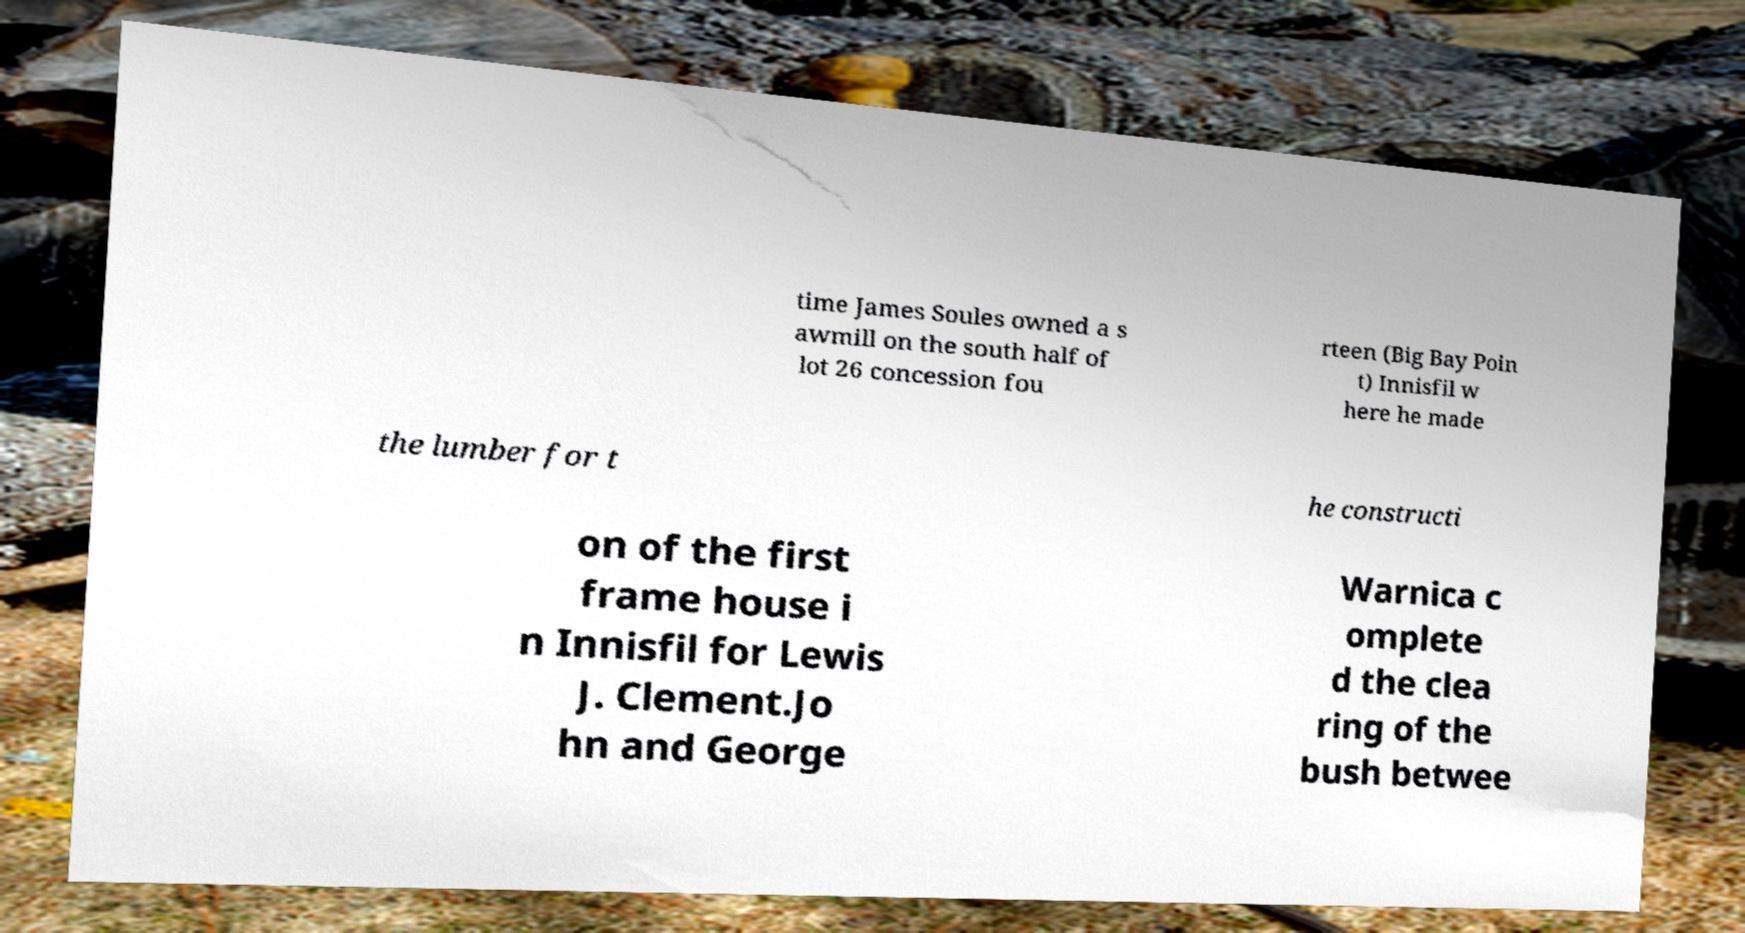I need the written content from this picture converted into text. Can you do that? time James Soules owned a s awmill on the south half of lot 26 concession fou rteen (Big Bay Poin t) Innisfil w here he made the lumber for t he constructi on of the first frame house i n Innisfil for Lewis J. Clement.Jo hn and George Warnica c omplete d the clea ring of the bush betwee 